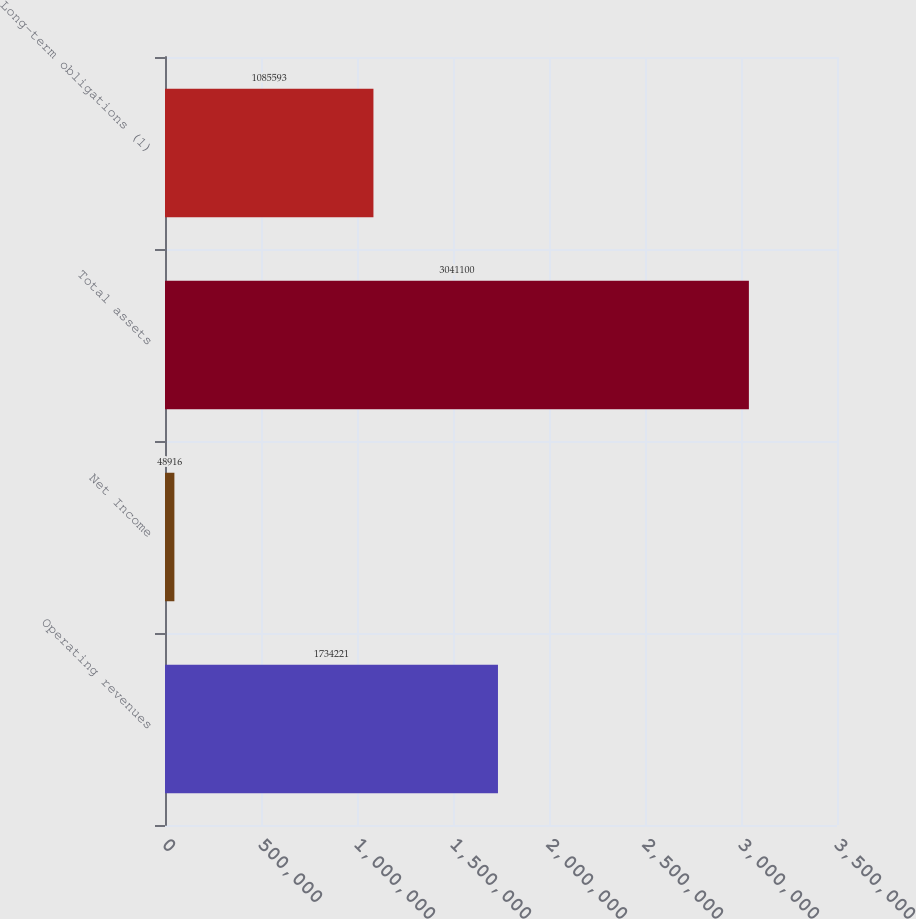Convert chart to OTSL. <chart><loc_0><loc_0><loc_500><loc_500><bar_chart><fcel>Operating revenues<fcel>Net Income<fcel>Total assets<fcel>Long-term obligations (1)<nl><fcel>1.73422e+06<fcel>48916<fcel>3.0411e+06<fcel>1.08559e+06<nl></chart> 